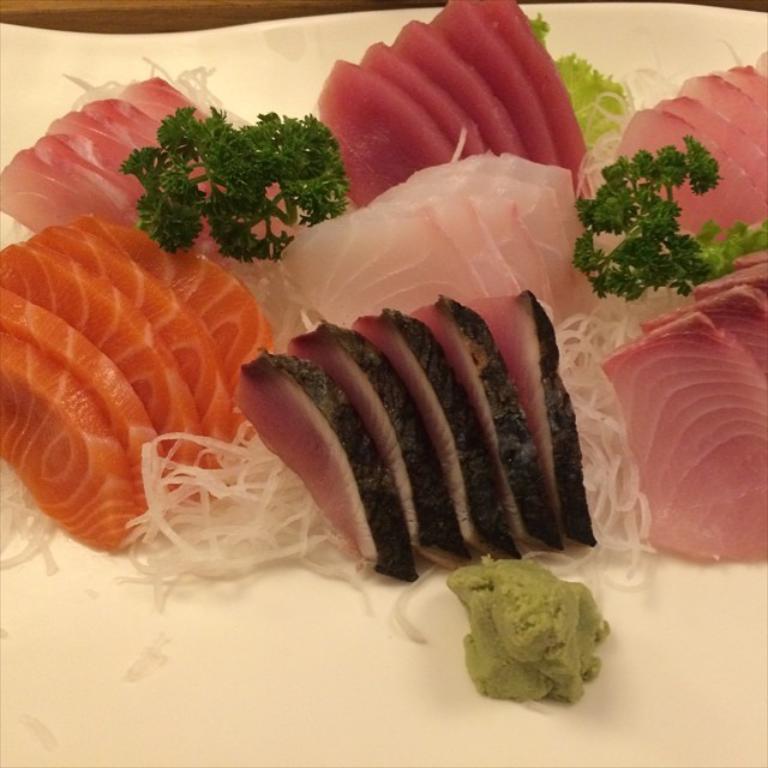In one or two sentences, can you explain what this image depicts? In this picture we can see the pieces of meat, tomatoes, onions, cucumber and mint on a plate. This plate is kept on the table. 